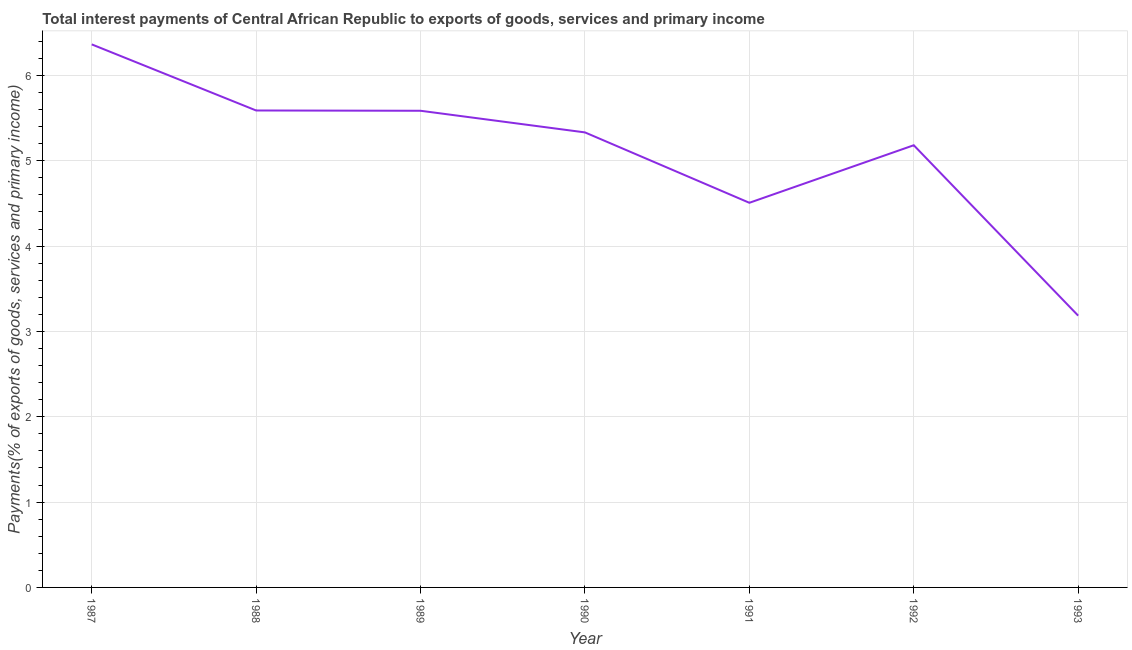What is the total interest payments on external debt in 1989?
Ensure brevity in your answer.  5.59. Across all years, what is the maximum total interest payments on external debt?
Provide a short and direct response. 6.36. Across all years, what is the minimum total interest payments on external debt?
Offer a terse response. 3.19. In which year was the total interest payments on external debt minimum?
Your answer should be very brief. 1993. What is the sum of the total interest payments on external debt?
Ensure brevity in your answer.  35.75. What is the difference between the total interest payments on external debt in 1988 and 1991?
Provide a short and direct response. 1.08. What is the average total interest payments on external debt per year?
Give a very brief answer. 5.11. What is the median total interest payments on external debt?
Ensure brevity in your answer.  5.33. Do a majority of the years between 1990 and 1993 (inclusive) have total interest payments on external debt greater than 5.2 %?
Your answer should be very brief. No. What is the ratio of the total interest payments on external debt in 1991 to that in 1993?
Your response must be concise. 1.42. Is the total interest payments on external debt in 1991 less than that in 1993?
Give a very brief answer. No. What is the difference between the highest and the second highest total interest payments on external debt?
Keep it short and to the point. 0.77. Is the sum of the total interest payments on external debt in 1987 and 1991 greater than the maximum total interest payments on external debt across all years?
Provide a short and direct response. Yes. What is the difference between the highest and the lowest total interest payments on external debt?
Make the answer very short. 3.18. Does the total interest payments on external debt monotonically increase over the years?
Provide a short and direct response. No. How many lines are there?
Give a very brief answer. 1. How many years are there in the graph?
Offer a very short reply. 7. What is the difference between two consecutive major ticks on the Y-axis?
Keep it short and to the point. 1. Are the values on the major ticks of Y-axis written in scientific E-notation?
Provide a succinct answer. No. What is the title of the graph?
Provide a succinct answer. Total interest payments of Central African Republic to exports of goods, services and primary income. What is the label or title of the X-axis?
Offer a terse response. Year. What is the label or title of the Y-axis?
Your response must be concise. Payments(% of exports of goods, services and primary income). What is the Payments(% of exports of goods, services and primary income) in 1987?
Give a very brief answer. 6.36. What is the Payments(% of exports of goods, services and primary income) of 1988?
Your answer should be compact. 5.59. What is the Payments(% of exports of goods, services and primary income) of 1989?
Your answer should be compact. 5.59. What is the Payments(% of exports of goods, services and primary income) of 1990?
Offer a very short reply. 5.33. What is the Payments(% of exports of goods, services and primary income) of 1991?
Your response must be concise. 4.51. What is the Payments(% of exports of goods, services and primary income) in 1992?
Provide a short and direct response. 5.18. What is the Payments(% of exports of goods, services and primary income) of 1993?
Make the answer very short. 3.19. What is the difference between the Payments(% of exports of goods, services and primary income) in 1987 and 1988?
Your answer should be compact. 0.77. What is the difference between the Payments(% of exports of goods, services and primary income) in 1987 and 1989?
Your answer should be compact. 0.78. What is the difference between the Payments(% of exports of goods, services and primary income) in 1987 and 1990?
Your answer should be compact. 1.03. What is the difference between the Payments(% of exports of goods, services and primary income) in 1987 and 1991?
Make the answer very short. 1.86. What is the difference between the Payments(% of exports of goods, services and primary income) in 1987 and 1992?
Your answer should be very brief. 1.18. What is the difference between the Payments(% of exports of goods, services and primary income) in 1987 and 1993?
Your answer should be very brief. 3.18. What is the difference between the Payments(% of exports of goods, services and primary income) in 1988 and 1989?
Provide a short and direct response. 0. What is the difference between the Payments(% of exports of goods, services and primary income) in 1988 and 1990?
Make the answer very short. 0.26. What is the difference between the Payments(% of exports of goods, services and primary income) in 1988 and 1991?
Offer a very short reply. 1.08. What is the difference between the Payments(% of exports of goods, services and primary income) in 1988 and 1992?
Keep it short and to the point. 0.41. What is the difference between the Payments(% of exports of goods, services and primary income) in 1988 and 1993?
Your answer should be compact. 2.4. What is the difference between the Payments(% of exports of goods, services and primary income) in 1989 and 1990?
Provide a succinct answer. 0.25. What is the difference between the Payments(% of exports of goods, services and primary income) in 1989 and 1991?
Your answer should be compact. 1.08. What is the difference between the Payments(% of exports of goods, services and primary income) in 1989 and 1992?
Your response must be concise. 0.4. What is the difference between the Payments(% of exports of goods, services and primary income) in 1989 and 1993?
Offer a terse response. 2.4. What is the difference between the Payments(% of exports of goods, services and primary income) in 1990 and 1991?
Give a very brief answer. 0.82. What is the difference between the Payments(% of exports of goods, services and primary income) in 1990 and 1992?
Offer a terse response. 0.15. What is the difference between the Payments(% of exports of goods, services and primary income) in 1990 and 1993?
Your answer should be very brief. 2.15. What is the difference between the Payments(% of exports of goods, services and primary income) in 1991 and 1992?
Your response must be concise. -0.67. What is the difference between the Payments(% of exports of goods, services and primary income) in 1991 and 1993?
Offer a terse response. 1.32. What is the difference between the Payments(% of exports of goods, services and primary income) in 1992 and 1993?
Make the answer very short. 2. What is the ratio of the Payments(% of exports of goods, services and primary income) in 1987 to that in 1988?
Your answer should be very brief. 1.14. What is the ratio of the Payments(% of exports of goods, services and primary income) in 1987 to that in 1989?
Offer a terse response. 1.14. What is the ratio of the Payments(% of exports of goods, services and primary income) in 1987 to that in 1990?
Provide a succinct answer. 1.19. What is the ratio of the Payments(% of exports of goods, services and primary income) in 1987 to that in 1991?
Give a very brief answer. 1.41. What is the ratio of the Payments(% of exports of goods, services and primary income) in 1987 to that in 1992?
Your answer should be very brief. 1.23. What is the ratio of the Payments(% of exports of goods, services and primary income) in 1987 to that in 1993?
Give a very brief answer. 2. What is the ratio of the Payments(% of exports of goods, services and primary income) in 1988 to that in 1990?
Your answer should be compact. 1.05. What is the ratio of the Payments(% of exports of goods, services and primary income) in 1988 to that in 1991?
Your answer should be compact. 1.24. What is the ratio of the Payments(% of exports of goods, services and primary income) in 1988 to that in 1992?
Offer a terse response. 1.08. What is the ratio of the Payments(% of exports of goods, services and primary income) in 1988 to that in 1993?
Provide a succinct answer. 1.75. What is the ratio of the Payments(% of exports of goods, services and primary income) in 1989 to that in 1990?
Offer a terse response. 1.05. What is the ratio of the Payments(% of exports of goods, services and primary income) in 1989 to that in 1991?
Provide a short and direct response. 1.24. What is the ratio of the Payments(% of exports of goods, services and primary income) in 1989 to that in 1992?
Give a very brief answer. 1.08. What is the ratio of the Payments(% of exports of goods, services and primary income) in 1989 to that in 1993?
Your answer should be very brief. 1.75. What is the ratio of the Payments(% of exports of goods, services and primary income) in 1990 to that in 1991?
Give a very brief answer. 1.18. What is the ratio of the Payments(% of exports of goods, services and primary income) in 1990 to that in 1992?
Offer a terse response. 1.03. What is the ratio of the Payments(% of exports of goods, services and primary income) in 1990 to that in 1993?
Provide a succinct answer. 1.67. What is the ratio of the Payments(% of exports of goods, services and primary income) in 1991 to that in 1992?
Keep it short and to the point. 0.87. What is the ratio of the Payments(% of exports of goods, services and primary income) in 1991 to that in 1993?
Ensure brevity in your answer.  1.42. What is the ratio of the Payments(% of exports of goods, services and primary income) in 1992 to that in 1993?
Keep it short and to the point. 1.63. 